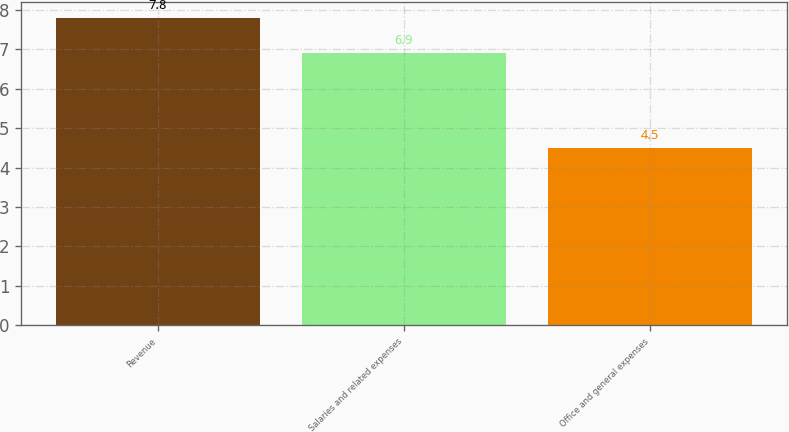Convert chart to OTSL. <chart><loc_0><loc_0><loc_500><loc_500><bar_chart><fcel>Revenue<fcel>Salaries and related expenses<fcel>Office and general expenses<nl><fcel>7.8<fcel>6.9<fcel>4.5<nl></chart> 